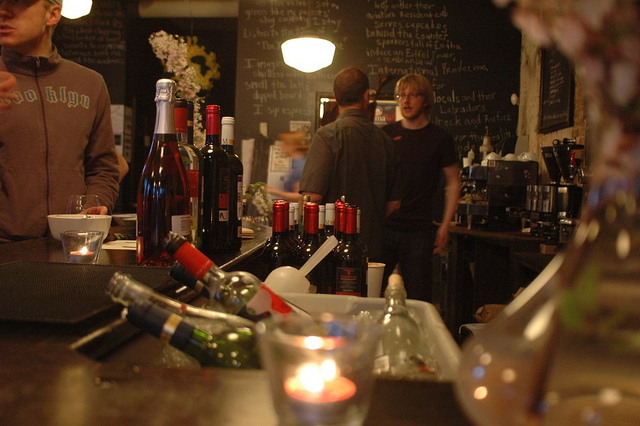Describe the atmosphere of the setting in the image. The image captures a cozy and bustling cafe or bar atmosphere. It features dim lighting, chalkboard menus, and the presence of candles and wine bottles contributing to a warm and inviting ambiance. What might be written on the chalkboard in the background? The chalkboard in the background likely lists the menu or special offers, typically seen in cafes and bars. Specific details cannot be discerned due to the angle and distance in the image. 